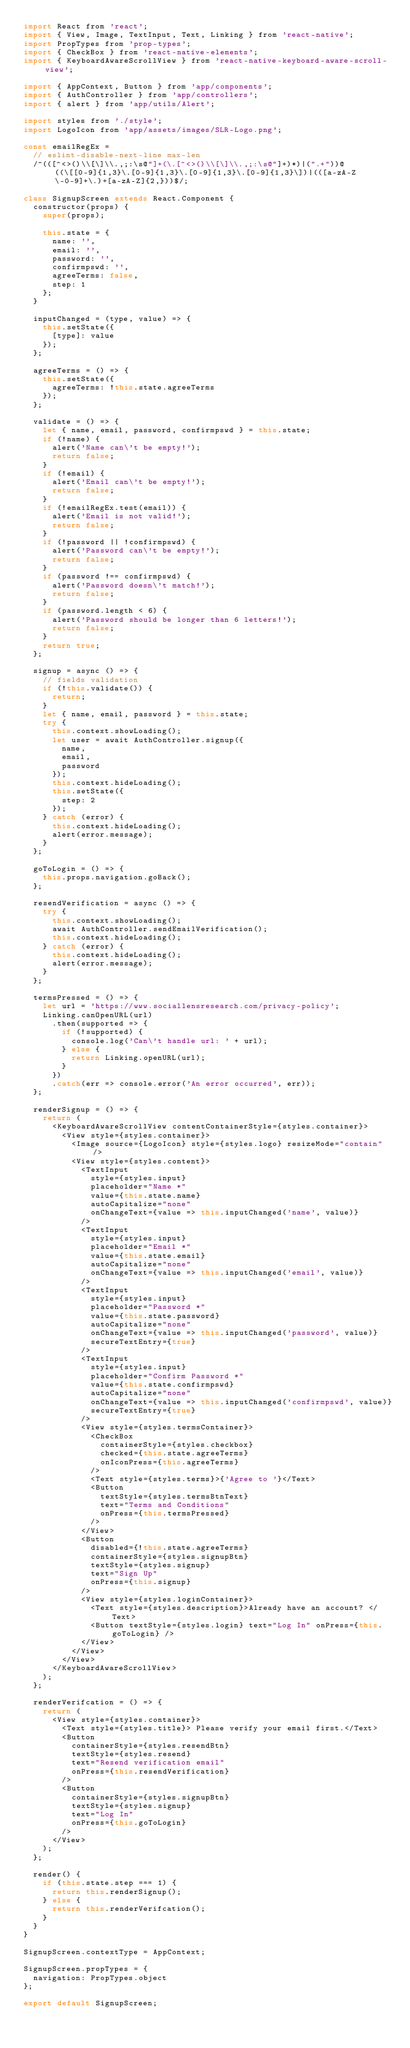Convert code to text. <code><loc_0><loc_0><loc_500><loc_500><_JavaScript_>import React from 'react';
import { View, Image, TextInput, Text, Linking } from 'react-native';
import PropTypes from 'prop-types';
import { CheckBox } from 'react-native-elements';
import { KeyboardAwareScrollView } from 'react-native-keyboard-aware-scroll-view';

import { AppContext, Button } from 'app/components';
import { AuthController } from 'app/controllers';
import { alert } from 'app/utils/Alert';

import styles from './style';
import LogoIcon from 'app/assets/images/SLR-Logo.png';

const emailRegEx =
  // eslint-disable-next-line max-len
  /^(([^<>()\\[\]\\.,;:\s@"]+(\.[^<>()\\[\]\\.,;:\s@"]+)*)|(".+"))@((\[[0-9]{1,3}\.[0-9]{1,3}\.[0-9]{1,3}\.[0-9]{1,3}\])|(([a-zA-Z\-0-9]+\.)+[a-zA-Z]{2,}))$/;

class SignupScreen extends React.Component {
  constructor(props) {
    super(props);

    this.state = {
      name: '',
      email: '',
      password: '',
      confirmpswd: '',
      agreeTerms: false,
      step: 1
    };
  }

  inputChanged = (type, value) => {
    this.setState({
      [type]: value
    });
  };

  agreeTerms = () => {
    this.setState({
      agreeTerms: !this.state.agreeTerms
    });
  };

  validate = () => {
    let { name, email, password, confirmpswd } = this.state;
    if (!name) {
      alert('Name can\'t be empty!');
      return false;
    }
    if (!email) {
      alert('Email can\'t be empty!');
      return false;
    }
    if (!emailRegEx.test(email)) {
      alert('Email is not valid!');
      return false;
    }
    if (!password || !confirmpswd) {
      alert('Password can\'t be empty!');
      return false;
    }
    if (password !== confirmpswd) {
      alert('Password doesn\'t match!');
      return false;
    }
    if (password.length < 6) {
      alert('Password should be longer than 6 letters!');
      return false;
    }
    return true;
  };

  signup = async () => {
    // fields validation
    if (!this.validate()) {
      return;
    }
    let { name, email, password } = this.state;
    try {
      this.context.showLoading();
      let user = await AuthController.signup({
        name,
        email,
        password
      });
      this.context.hideLoading();
      this.setState({
        step: 2
      });
    } catch (error) {
      this.context.hideLoading();
      alert(error.message);
    }
  };

  goToLogin = () => {
    this.props.navigation.goBack();
  };

  resendVerification = async () => {
    try {
      this.context.showLoading();
      await AuthController.sendEmailVerification();
      this.context.hideLoading();
    } catch (error) {
      this.context.hideLoading();
      alert(error.message);
    }
  };

  termsPressed = () => {
    let url = 'https://www.sociallensresearch.com/privacy-policy';
    Linking.canOpenURL(url)
      .then(supported => {
        if (!supported) {
          console.log('Can\'t handle url: ' + url);
        } else {
          return Linking.openURL(url);
        }
      })
      .catch(err => console.error('An error occurred', err));
  };

  renderSignup = () => {
    return (
      <KeyboardAwareScrollView contentContainerStyle={styles.container}>
        <View style={styles.container}>
          <Image source={LogoIcon} style={styles.logo} resizeMode="contain" />
          <View style={styles.content}>
            <TextInput
              style={styles.input}
              placeholder="Name *"
              value={this.state.name}
              autoCapitalize="none"
              onChangeText={value => this.inputChanged('name', value)}
            />
            <TextInput
              style={styles.input}
              placeholder="Email *"
              value={this.state.email}
              autoCapitalize="none"
              onChangeText={value => this.inputChanged('email', value)}
            />
            <TextInput
              style={styles.input}
              placeholder="Password *"
              value={this.state.password}
              autoCapitalize="none"
              onChangeText={value => this.inputChanged('password', value)}
              secureTextEntry={true}
            />
            <TextInput
              style={styles.input}
              placeholder="Confirm Password *"
              value={this.state.confirmpswd}
              autoCapitalize="none"
              onChangeText={value => this.inputChanged('confirmpswd', value)}
              secureTextEntry={true}
            />
            <View style={styles.termsContainer}>
              <CheckBox
                containerStyle={styles.checkbox}
                checked={this.state.agreeTerms}
                onIconPress={this.agreeTerms}
              />
              <Text style={styles.terms}>{'Agree to '}</Text>
              <Button
                textStyle={styles.termsBtnText}
                text="Terms and Conditions"
                onPress={this.termsPressed}
              />
            </View>
            <Button
              disabled={!this.state.agreeTerms}
              containerStyle={styles.signupBtn}
              textStyle={styles.signup}
              text="Sign Up"
              onPress={this.signup}
            />
            <View style={styles.loginContainer}>
              <Text style={styles.description}>Already have an account? </Text>
              <Button textStyle={styles.login} text="Log In" onPress={this.goToLogin} />
            </View>
          </View>
        </View>
      </KeyboardAwareScrollView>
    );
  };

  renderVerifcation = () => {
    return (
      <View style={styles.container}>
        <Text style={styles.title}> Please verify your email first.</Text>
        <Button
          containerStyle={styles.resendBtn}
          textStyle={styles.resend}
          text="Resend verification email"
          onPress={this.resendVerification}
        />
        <Button
          containerStyle={styles.signupBtn}
          textStyle={styles.signup}
          text="Log In"
          onPress={this.goToLogin}
        />
      </View>
    );
  };

  render() {
    if (this.state.step === 1) {
      return this.renderSignup();
    } else {
      return this.renderVerifcation();
    }
  }
}

SignupScreen.contextType = AppContext;

SignupScreen.propTypes = {
  navigation: PropTypes.object
};

export default SignupScreen;
</code> 